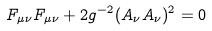Convert formula to latex. <formula><loc_0><loc_0><loc_500><loc_500>F _ { \mu \nu } F _ { \mu \nu } + 2 g ^ { - 2 } ( A _ { \nu } A _ { \nu } ) ^ { 2 } = 0</formula> 